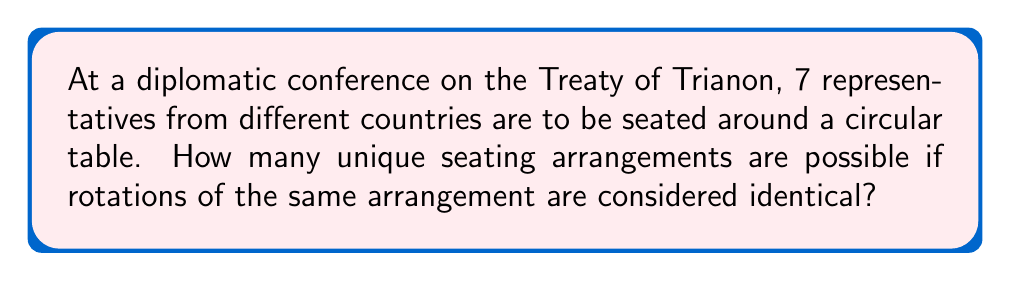Provide a solution to this math problem. Let's approach this step-by-step:

1) First, we need to recognize that this is a circular permutation problem. In a circular arrangement, rotations of the same arrangement are considered identical.

2) For linear arrangements of $n$ distinct objects, we would use $n!$ (n factorial). However, for circular arrangements, we divide by $n$ to account for the rotational symmetry.

3) The formula for circular permutations of $n$ distinct objects is:

   $$(n-1)!$$

4) In this case, we have 7 representatives, so $n = 7$.

5) Applying the formula:

   $$(7-1)! = 6!$$

6) Let's calculate 6!:

   $$6! = 6 \times 5 \times 4 \times 3 \times 2 \times 1 = 720$$

Therefore, there are 720 unique seating arrangements for the 7 diplomats around the circular conference table.
Answer: 720 